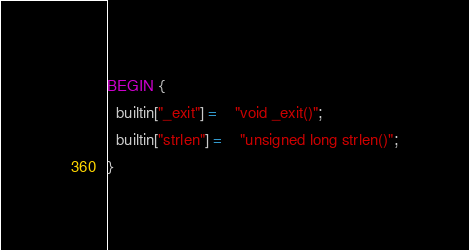<code> <loc_0><loc_0><loc_500><loc_500><_Awk_>BEGIN {
  builtin["_exit"] =	"void _exit()";
  builtin["strlen"] =	"unsigned long strlen()";
}
</code> 